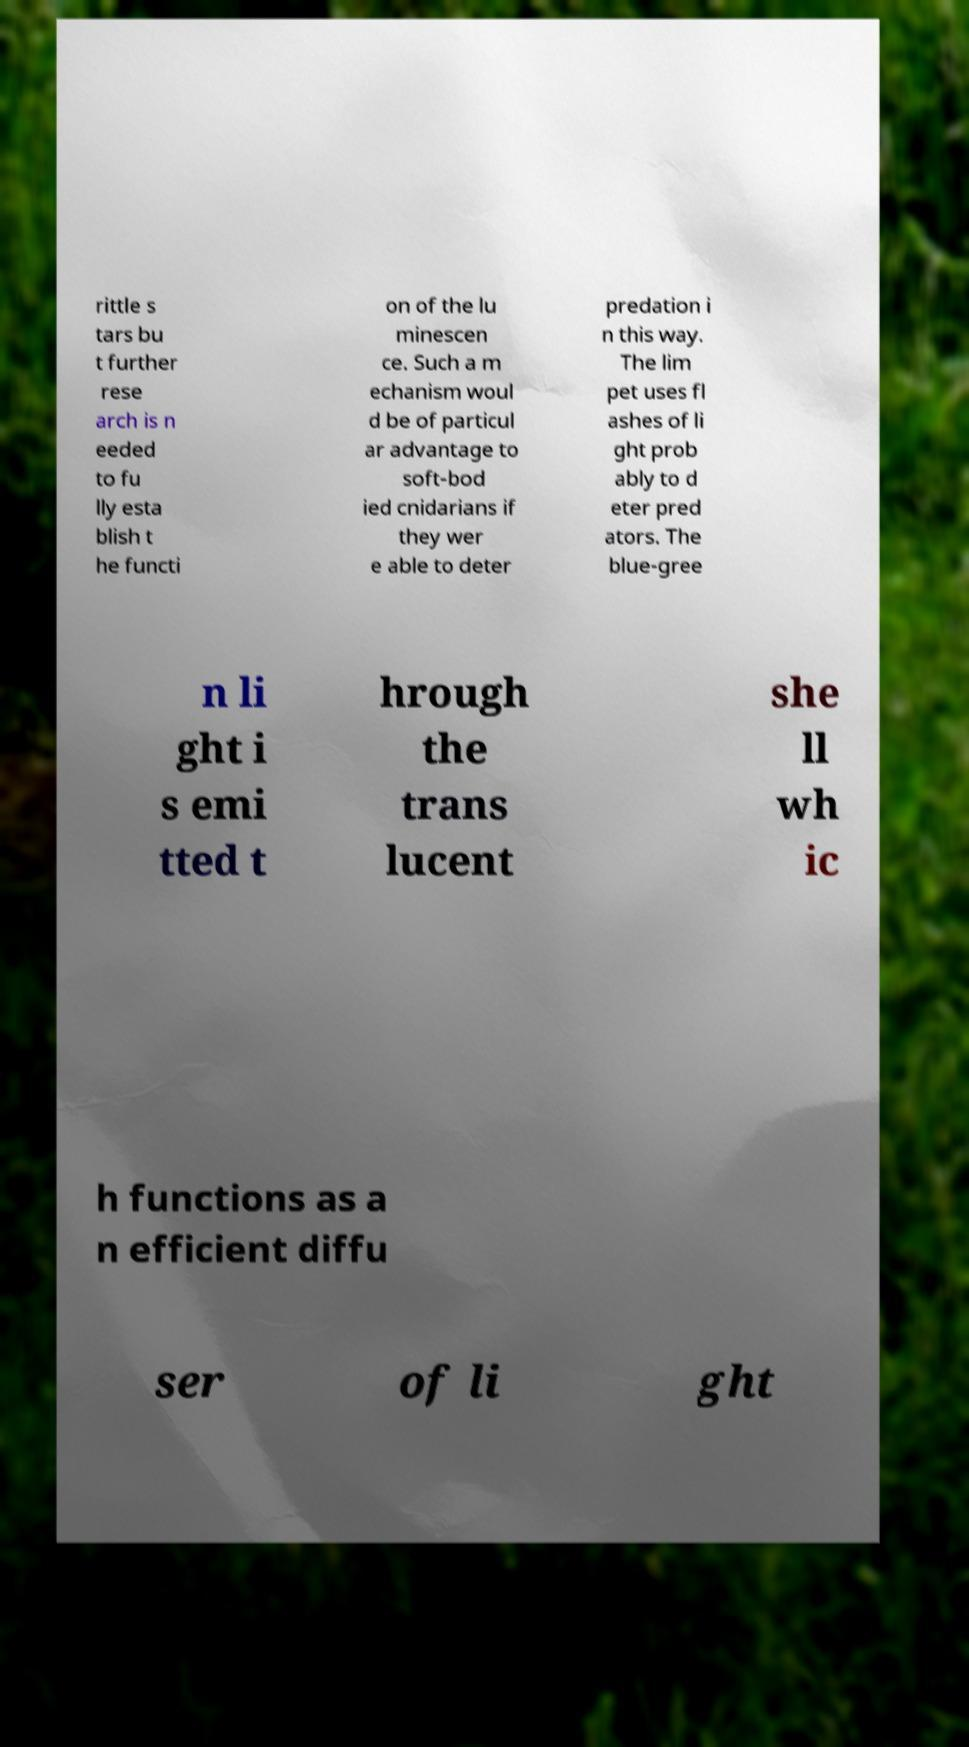There's text embedded in this image that I need extracted. Can you transcribe it verbatim? rittle s tars bu t further rese arch is n eeded to fu lly esta blish t he functi on of the lu minescen ce. Such a m echanism woul d be of particul ar advantage to soft-bod ied cnidarians if they wer e able to deter predation i n this way. The lim pet uses fl ashes of li ght prob ably to d eter pred ators. The blue-gree n li ght i s emi tted t hrough the trans lucent she ll wh ic h functions as a n efficient diffu ser of li ght 